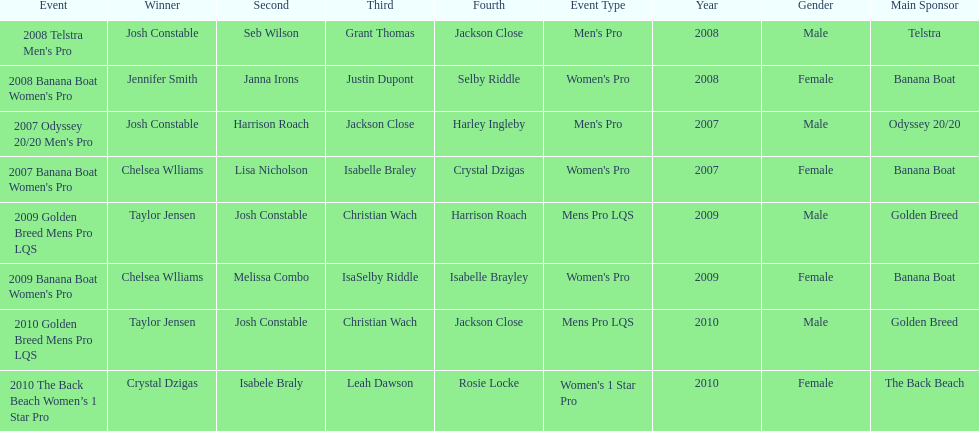Who was the top performer in the 2008 telstra men's pro? Josh Constable. 